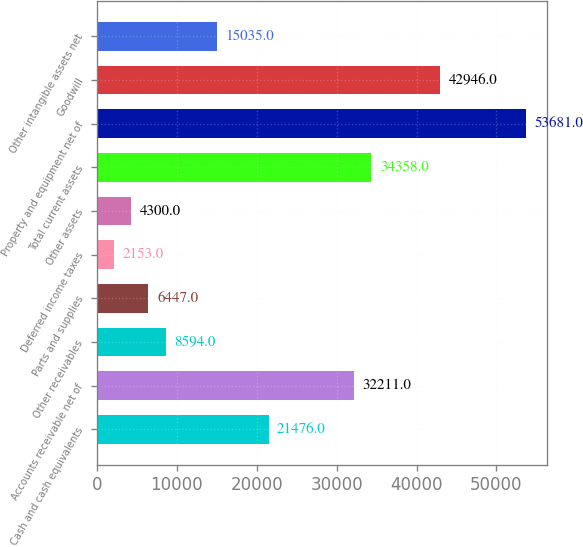Convert chart. <chart><loc_0><loc_0><loc_500><loc_500><bar_chart><fcel>Cash and cash equivalents<fcel>Accounts receivable net of<fcel>Other receivables<fcel>Parts and supplies<fcel>Deferred income taxes<fcel>Other assets<fcel>Total current assets<fcel>Property and equipment net of<fcel>Goodwill<fcel>Other intangible assets net<nl><fcel>21476<fcel>32211<fcel>8594<fcel>6447<fcel>2153<fcel>4300<fcel>34358<fcel>53681<fcel>42946<fcel>15035<nl></chart> 